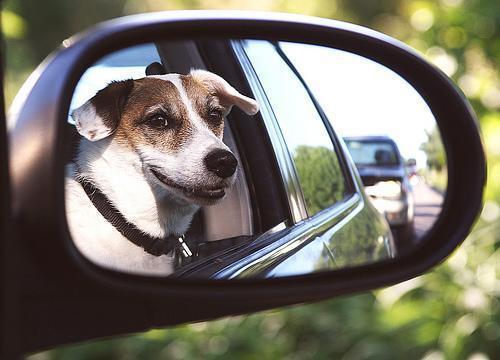How many cars are reflected in the mirror?
Give a very brief answer. 2. 